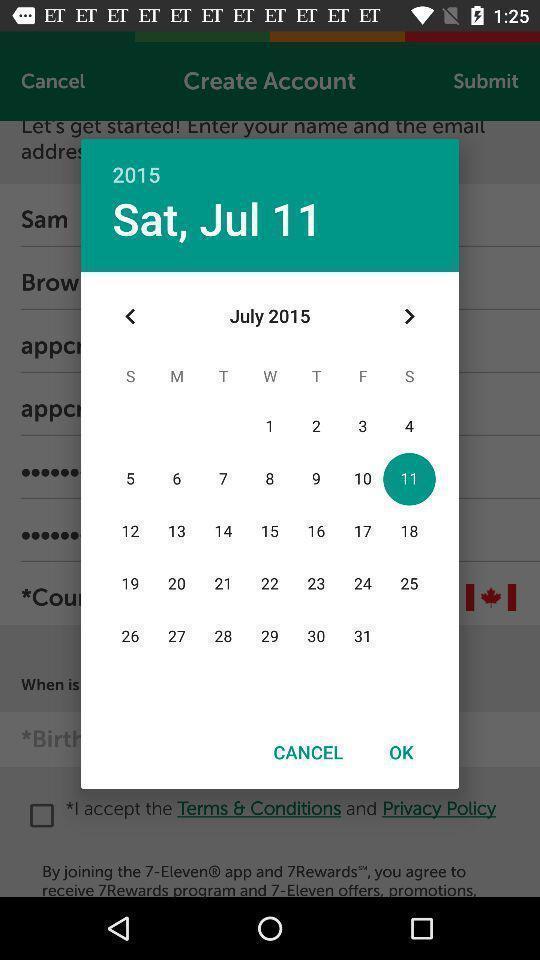What is the overall content of this screenshot? Pop-up showing calendar of a month. 